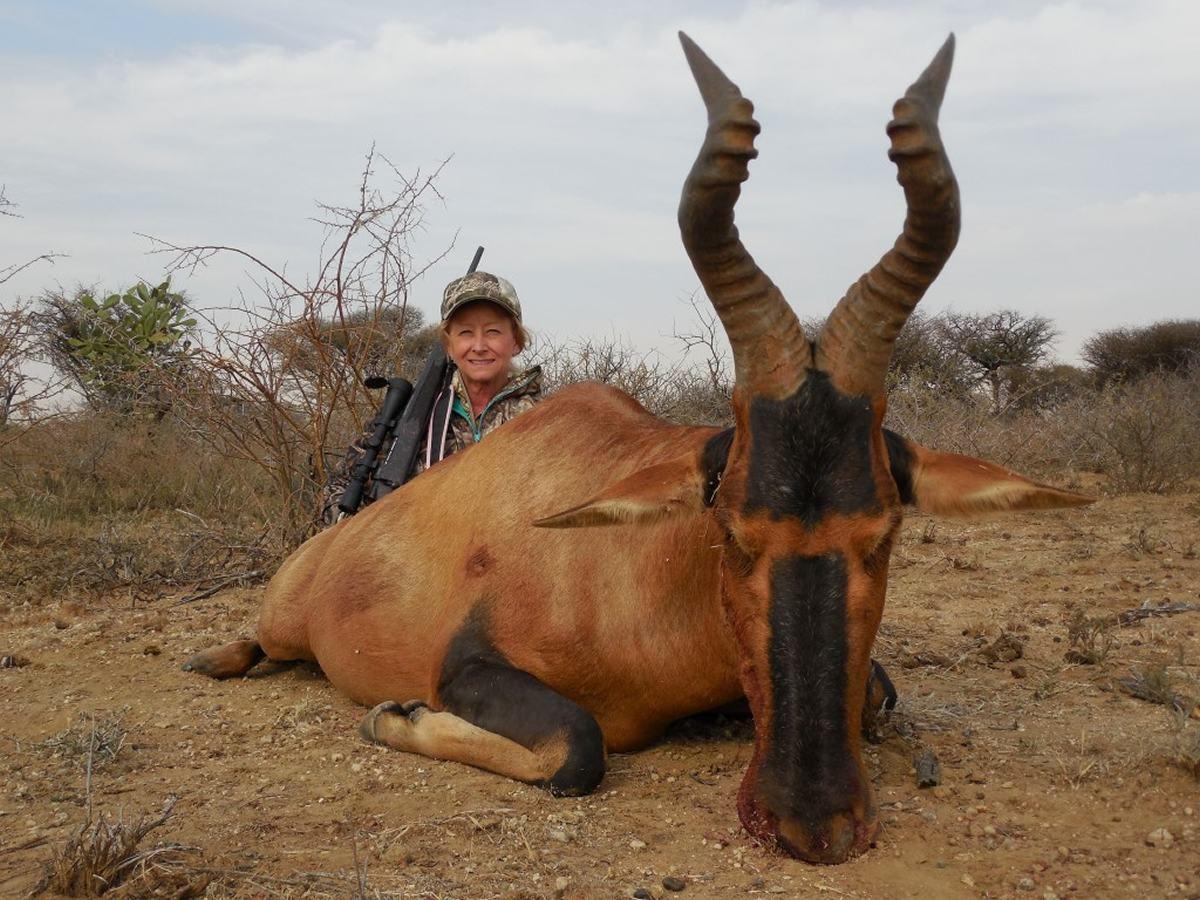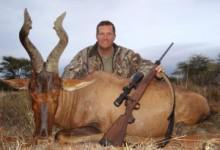The first image is the image on the left, the second image is the image on the right. Given the left and right images, does the statement "At least one of the images shows a human posing behind a horned animal." hold true? Answer yes or no. Yes. The first image is the image on the left, the second image is the image on the right. Analyze the images presented: Is the assertion "A hunter in camo is posed behind a downed long-horned animal, with his weapon propped against the animal's front." valid? Answer yes or no. Yes. 